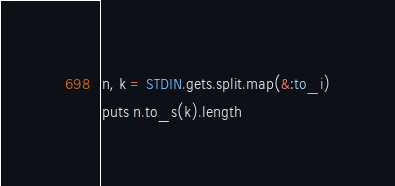<code> <loc_0><loc_0><loc_500><loc_500><_Ruby_>n, k = STDIN.gets.split.map(&:to_i)
puts n.to_s(k).length</code> 